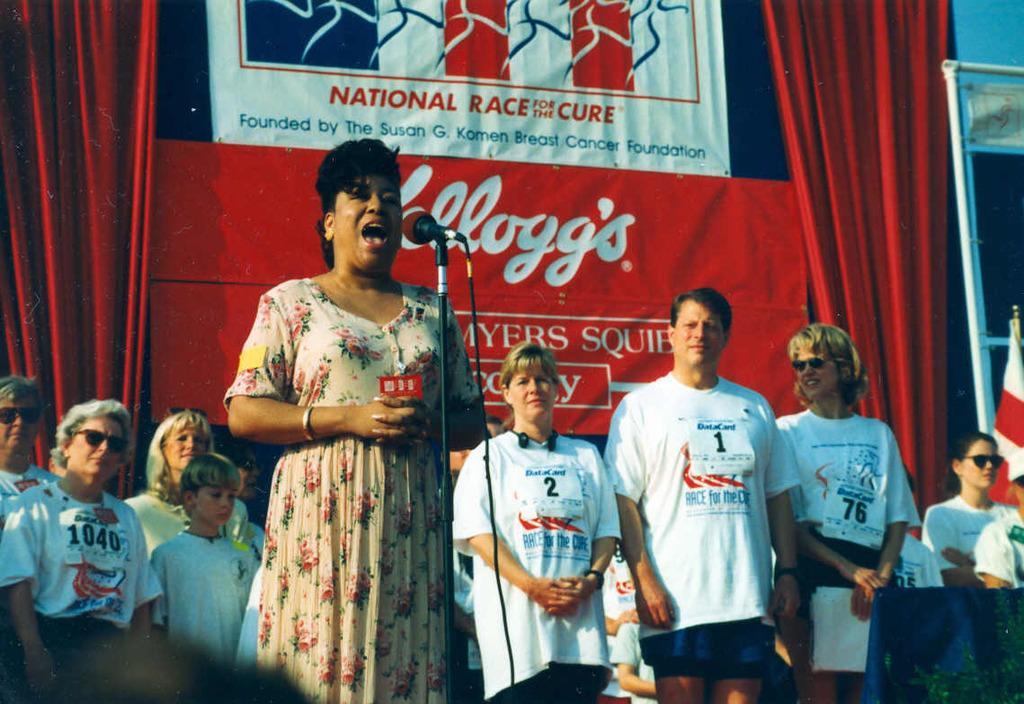Describe this image in one or two sentences. In the image we can see there is a woman standing and there is a mic with a stand. Behind her there are other people standing and there is a banner. 